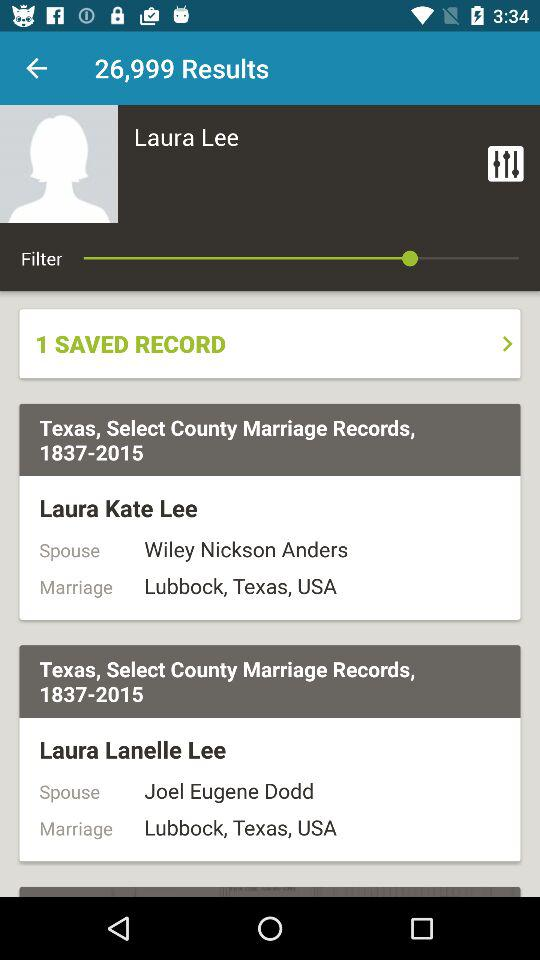What is the name of the user? The name of the user is Laura Lee. 